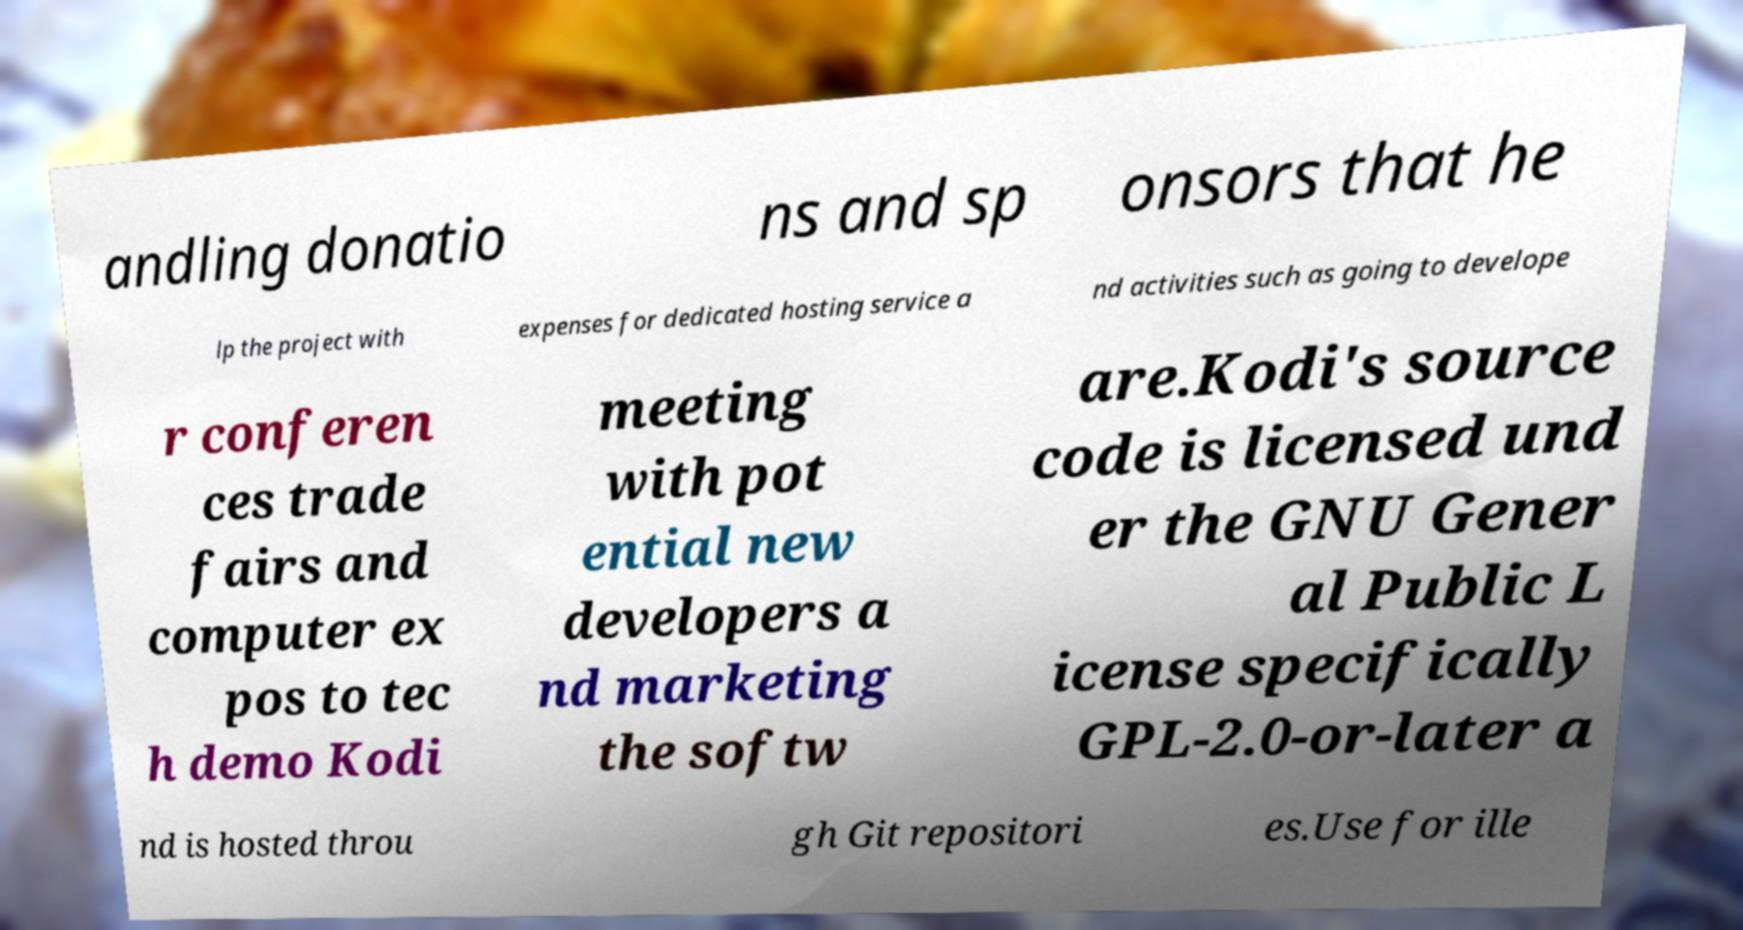There's text embedded in this image that I need extracted. Can you transcribe it verbatim? andling donatio ns and sp onsors that he lp the project with expenses for dedicated hosting service a nd activities such as going to develope r conferen ces trade fairs and computer ex pos to tec h demo Kodi meeting with pot ential new developers a nd marketing the softw are.Kodi's source code is licensed und er the GNU Gener al Public L icense specifically GPL-2.0-or-later a nd is hosted throu gh Git repositori es.Use for ille 